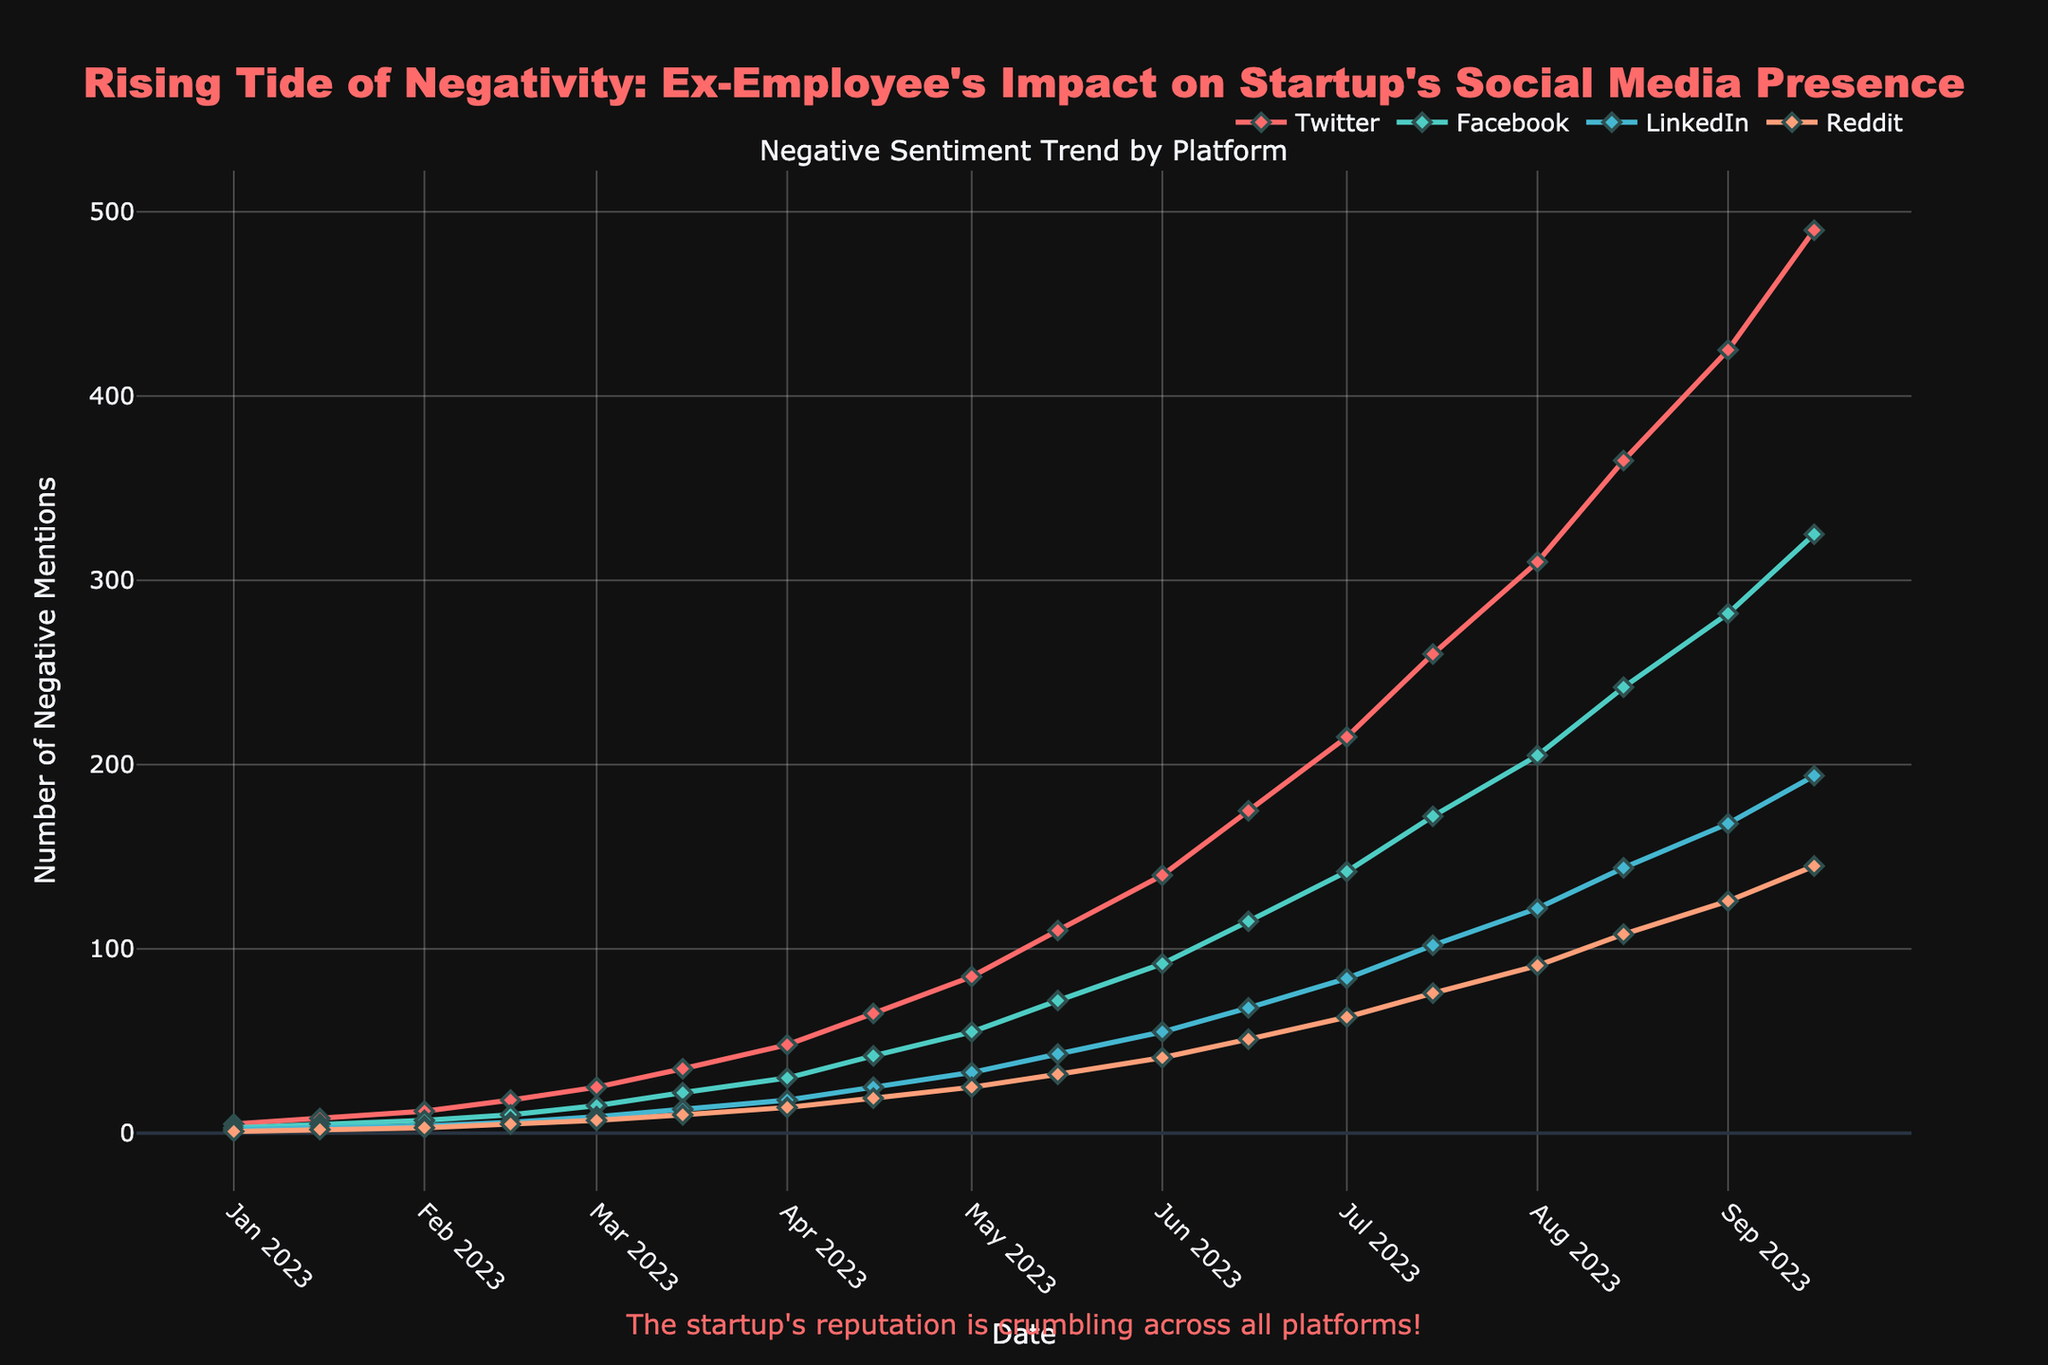Which platform had the highest number of negative mentions on 2023-09-15? Look for the 2023-09-15 date on the x-axis. Compare the heights of the markers for Twitter, Facebook, LinkedIn, and Reddit on this date. The highest marker corresponds to Twitter.
Answer: Twitter Which platform showed the fastest increase in negative mentions between 2023-01-01 and 2023-09-15? Calculate the difference in negative mentions for each platform between 2023-01-01 and 2023-09-15. Twitter increased from 5 to 490 (485 increase), Facebook from 3 to 325 (322 increase), LinkedIn from 2 to 194 (192 increase), and Reddit from 1 to 145 (144 increase). Twitter showed the fastest increase.
Answer: Twitter By how many did the negative mentions on Twitter increase between 2023-05-01 and 2023-06-15? Identify the negative mentions for Twitter on 2023-05-01 (85) and 2023-06-15 (175), and subtract the former from the latter: 175 - 85 = 90.
Answer: 90 Which two platforms had the closest number of negative mentions on 2023-09-01? Look at the values for Facebook (282) and LinkedIn (168) on 2023-09-01. Calculate the differences between pairs: Twitter and Facebook (425-282 = 143), Twitter and LinkedIn (425-168 = 257), Twitter and Reddit (425-126 = 299), Facebook and LinkedIn (282-168 = 114), Facebook and Reddit (282-126 = 156), LinkedIn and Reddit (168-126 = 42). The smallest difference is between LinkedIn and Reddit (42).
Answer: LinkedIn and Reddit What was the total number of negative mentions across all platforms on 2023-07-01? Sum the negative mentions for Twitter (215), Facebook (142), LinkedIn (84), and Reddit (63) on 2023-07-01. The total is 215 + 142 + 84 + 63 = 504.
Answer: 504 On which date did Facebook first surpass 100 negative mentions? Find the date where Facebook's negative mentions first exceed 100. Reviewing the data, Facebook had 72 mentions on 2023-06-15 and 142 mentions on 2023-07-01, so it first surpassed 100 on 2023-07-01.
Answer: 2023-07-01 How many more negative mentions did Reddit have on 2023-08-01 compared to LinkedIn on 2023-04-01? Check Reddit's count on 2023-08-01 (91) and LinkedIn's count on 2023-04-01 (18). Subtract the latter from the former: 91 - 18 = 73.
Answer: 73 Which month saw the largest increase in negative mentions for Reddit? Calculate the increase in Reddit's negative mentions for each month by comparing values at the start and middle of each month. The largest increase occurs between 2023-08-01 (91) and 2023-08-15 (108), resulting in an increase of 108 - 91 = 17. No other monthly increase exceeds this.
Answer: August 